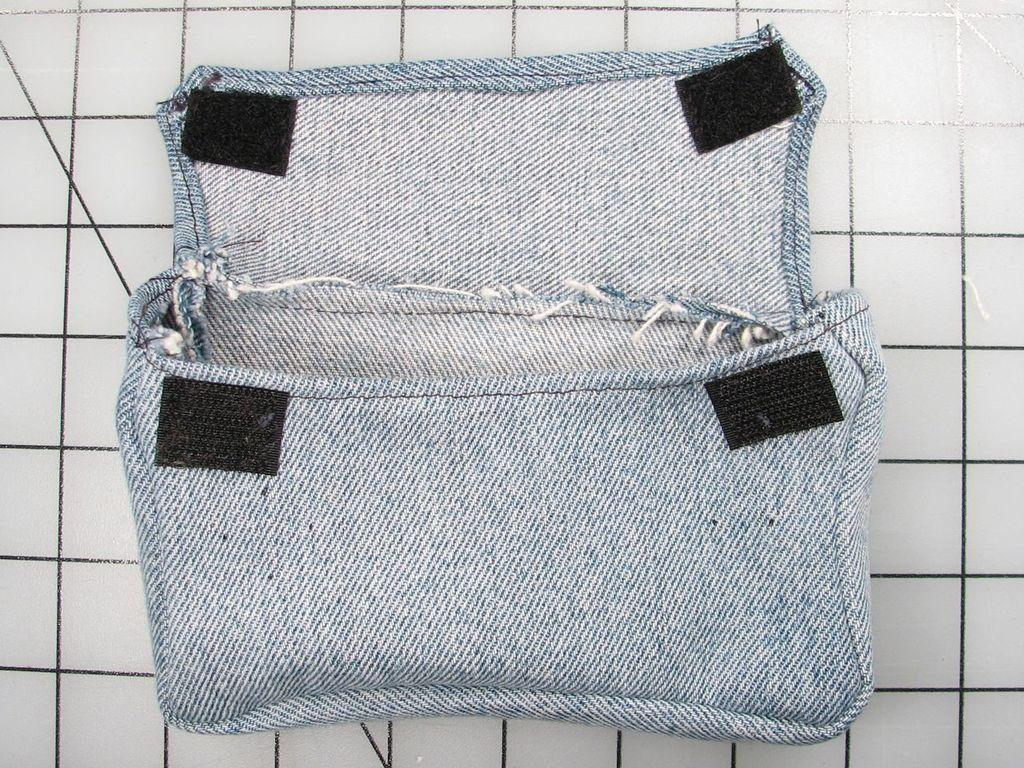What type of accessory is visible in the image? There is a hand purse in the image. What color is the background of the image? The background of the image is white. Is there a knife being used for pleasure in the image? There is no knife or any indication of pleasure in the image; it only features a hand purse against a white background. 